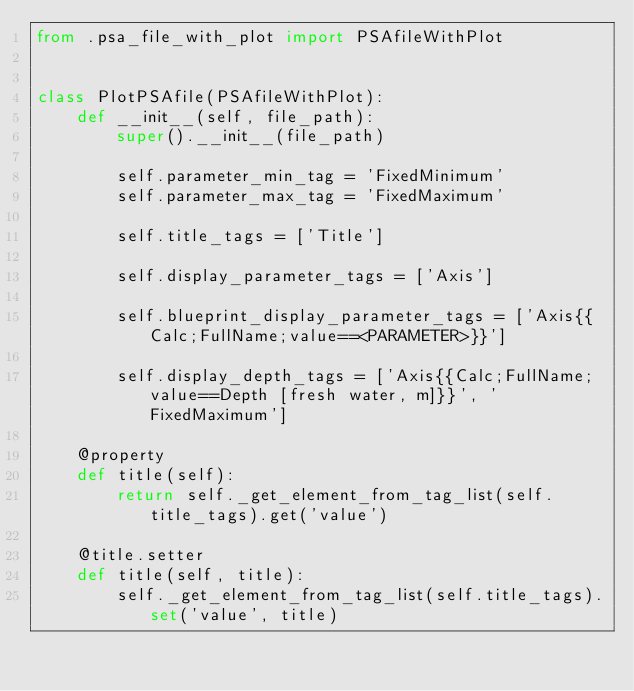<code> <loc_0><loc_0><loc_500><loc_500><_Python_>from .psa_file_with_plot import PSAfileWithPlot


class PlotPSAfile(PSAfileWithPlot):
    def __init__(self, file_path):
        super().__init__(file_path)

        self.parameter_min_tag = 'FixedMinimum'
        self.parameter_max_tag = 'FixedMaximum'

        self.title_tags = ['Title']

        self.display_parameter_tags = ['Axis']

        self.blueprint_display_parameter_tags = ['Axis{{Calc;FullName;value==<PARAMETER>}}']

        self.display_depth_tags = ['Axis{{Calc;FullName;value==Depth [fresh water, m]}}', 'FixedMaximum']

    @property
    def title(self):
        return self._get_element_from_tag_list(self.title_tags).get('value')

    @title.setter
    def title(self, title):
        self._get_element_from_tag_list(self.title_tags).set('value', title)</code> 